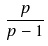Convert formula to latex. <formula><loc_0><loc_0><loc_500><loc_500>\frac { p } { p - 1 }</formula> 